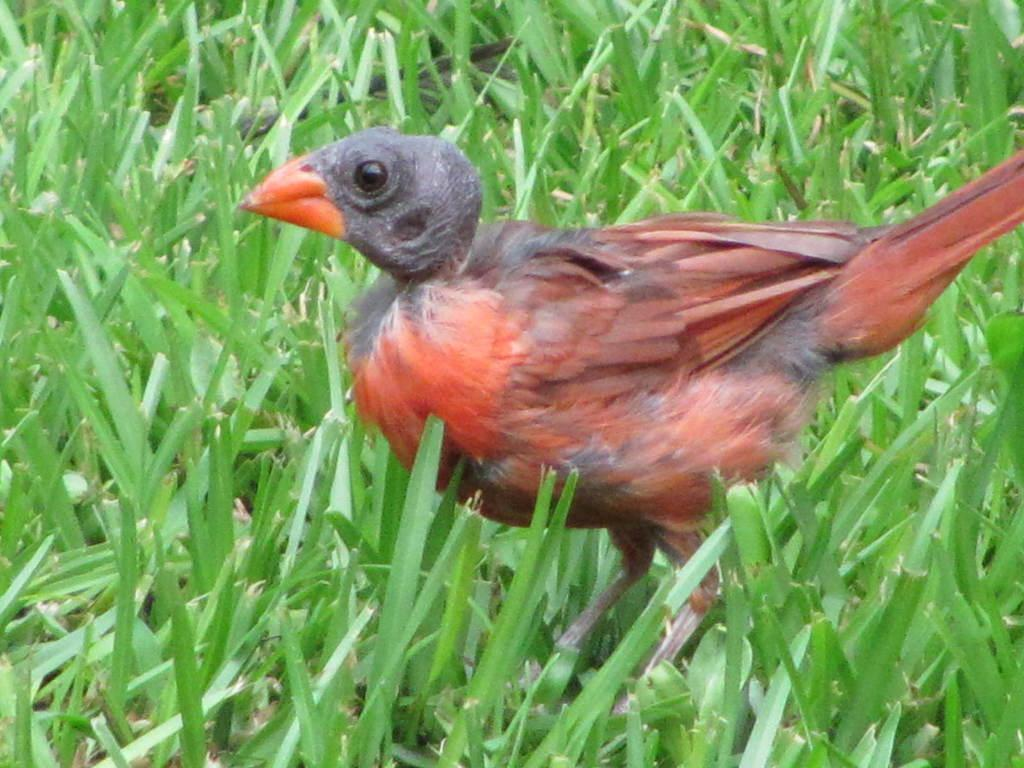What type of animal can be seen in the picture? There is a bird in the picture. Where is the bird located? The bird is on the land. What colors can be observed on the bird? The bird has black and red coloring. What type of vegetation is present on the ground? There is grass on the ground. What type of bait is the bird using to catch fish in the image? There is no bait or fish present in the image; it features a bird on the land with grass. What type of lipstick is the bird wearing in the image? There is no lipstick or indication of makeup on the bird in the image. 